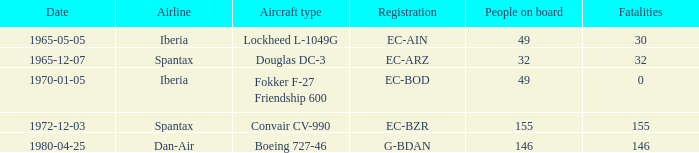How many deaths have been reported for the lockheed l-1049g? 30.0. 